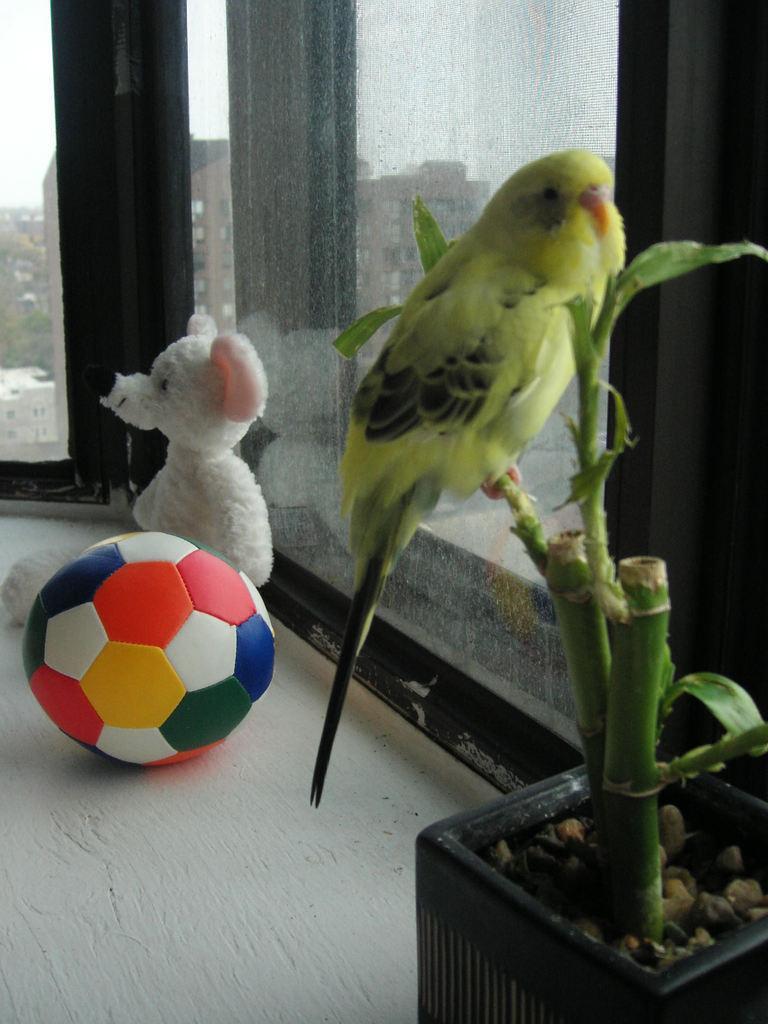Describe this image in one or two sentences. In this image we can see there is a parrot sitting in the stem of the plant, behind that there is a ball and teddy bear. 